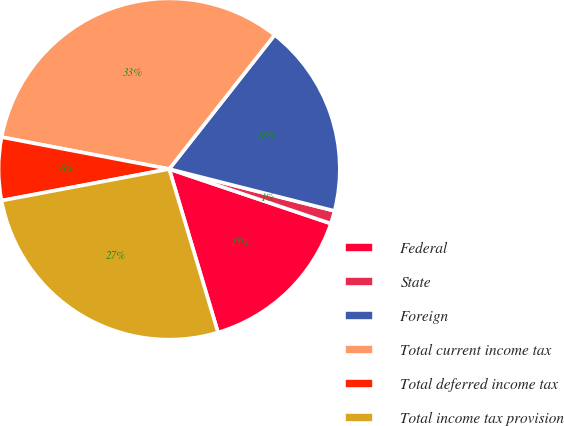Convert chart to OTSL. <chart><loc_0><loc_0><loc_500><loc_500><pie_chart><fcel>Federal<fcel>State<fcel>Foreign<fcel>Total current income tax<fcel>Total deferred income tax<fcel>Total income tax provision<nl><fcel>15.2%<fcel>1.23%<fcel>18.34%<fcel>32.61%<fcel>5.96%<fcel>26.65%<nl></chart> 